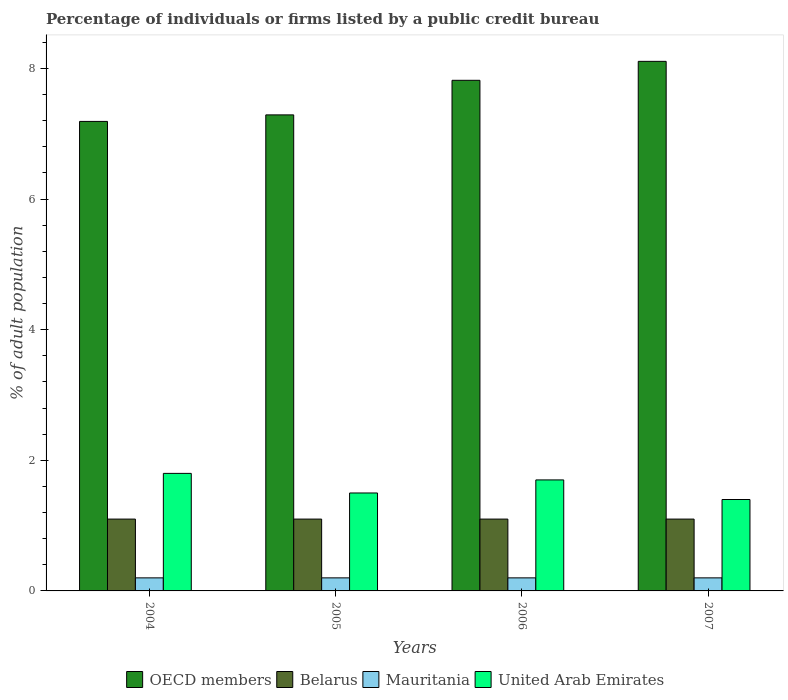How many groups of bars are there?
Keep it short and to the point. 4. Are the number of bars per tick equal to the number of legend labels?
Offer a terse response. Yes. Are the number of bars on each tick of the X-axis equal?
Give a very brief answer. Yes. How many bars are there on the 4th tick from the left?
Ensure brevity in your answer.  4. How many bars are there on the 1st tick from the right?
Provide a short and direct response. 4. Across all years, what is the maximum percentage of population listed by a public credit bureau in Belarus?
Your response must be concise. 1.1. In which year was the percentage of population listed by a public credit bureau in Belarus minimum?
Provide a succinct answer. 2004. What is the total percentage of population listed by a public credit bureau in Mauritania in the graph?
Give a very brief answer. 0.8. What is the difference between the percentage of population listed by a public credit bureau in OECD members in 2007 and the percentage of population listed by a public credit bureau in Mauritania in 2004?
Provide a short and direct response. 7.91. In the year 2006, what is the difference between the percentage of population listed by a public credit bureau in United Arab Emirates and percentage of population listed by a public credit bureau in Belarus?
Give a very brief answer. 0.6. What is the ratio of the percentage of population listed by a public credit bureau in OECD members in 2005 to that in 2006?
Make the answer very short. 0.93. Is the percentage of population listed by a public credit bureau in Mauritania in 2004 less than that in 2007?
Your response must be concise. No. What is the difference between the highest and the second highest percentage of population listed by a public credit bureau in United Arab Emirates?
Your response must be concise. 0.1. Is the sum of the percentage of population listed by a public credit bureau in Mauritania in 2006 and 2007 greater than the maximum percentage of population listed by a public credit bureau in Belarus across all years?
Offer a very short reply. No. Is it the case that in every year, the sum of the percentage of population listed by a public credit bureau in United Arab Emirates and percentage of population listed by a public credit bureau in OECD members is greater than the sum of percentage of population listed by a public credit bureau in Belarus and percentage of population listed by a public credit bureau in Mauritania?
Offer a very short reply. Yes. What does the 1st bar from the left in 2005 represents?
Give a very brief answer. OECD members. What does the 3rd bar from the right in 2007 represents?
Your answer should be compact. Belarus. Are all the bars in the graph horizontal?
Provide a short and direct response. No. How many years are there in the graph?
Give a very brief answer. 4. Where does the legend appear in the graph?
Your answer should be very brief. Bottom center. How are the legend labels stacked?
Your answer should be very brief. Horizontal. What is the title of the graph?
Provide a short and direct response. Percentage of individuals or firms listed by a public credit bureau. What is the label or title of the X-axis?
Ensure brevity in your answer.  Years. What is the label or title of the Y-axis?
Ensure brevity in your answer.  % of adult population. What is the % of adult population of OECD members in 2004?
Provide a succinct answer. 7.19. What is the % of adult population of United Arab Emirates in 2004?
Offer a very short reply. 1.8. What is the % of adult population in OECD members in 2005?
Offer a terse response. 7.29. What is the % of adult population in United Arab Emirates in 2005?
Make the answer very short. 1.5. What is the % of adult population of OECD members in 2006?
Provide a short and direct response. 7.82. What is the % of adult population in United Arab Emirates in 2006?
Ensure brevity in your answer.  1.7. What is the % of adult population in OECD members in 2007?
Make the answer very short. 8.11. What is the % of adult population of Belarus in 2007?
Provide a short and direct response. 1.1. Across all years, what is the maximum % of adult population in OECD members?
Your answer should be very brief. 8.11. Across all years, what is the maximum % of adult population in Mauritania?
Your response must be concise. 0.2. Across all years, what is the maximum % of adult population in United Arab Emirates?
Your answer should be very brief. 1.8. Across all years, what is the minimum % of adult population in OECD members?
Your response must be concise. 7.19. Across all years, what is the minimum % of adult population of Belarus?
Keep it short and to the point. 1.1. Across all years, what is the minimum % of adult population in Mauritania?
Keep it short and to the point. 0.2. Across all years, what is the minimum % of adult population of United Arab Emirates?
Ensure brevity in your answer.  1.4. What is the total % of adult population of OECD members in the graph?
Provide a short and direct response. 30.41. What is the total % of adult population of Belarus in the graph?
Offer a terse response. 4.4. What is the total % of adult population in Mauritania in the graph?
Your answer should be very brief. 0.8. What is the difference between the % of adult population of United Arab Emirates in 2004 and that in 2005?
Provide a succinct answer. 0.3. What is the difference between the % of adult population of OECD members in 2004 and that in 2006?
Keep it short and to the point. -0.63. What is the difference between the % of adult population of United Arab Emirates in 2004 and that in 2006?
Give a very brief answer. 0.1. What is the difference between the % of adult population of OECD members in 2004 and that in 2007?
Offer a terse response. -0.92. What is the difference between the % of adult population in Mauritania in 2004 and that in 2007?
Provide a short and direct response. 0. What is the difference between the % of adult population of United Arab Emirates in 2004 and that in 2007?
Make the answer very short. 0.4. What is the difference between the % of adult population in OECD members in 2005 and that in 2006?
Offer a very short reply. -0.53. What is the difference between the % of adult population of United Arab Emirates in 2005 and that in 2006?
Give a very brief answer. -0.2. What is the difference between the % of adult population in OECD members in 2005 and that in 2007?
Your answer should be compact. -0.82. What is the difference between the % of adult population of Belarus in 2005 and that in 2007?
Offer a very short reply. 0. What is the difference between the % of adult population in Mauritania in 2005 and that in 2007?
Provide a short and direct response. 0. What is the difference between the % of adult population in OECD members in 2006 and that in 2007?
Give a very brief answer. -0.29. What is the difference between the % of adult population of Mauritania in 2006 and that in 2007?
Keep it short and to the point. 0. What is the difference between the % of adult population in OECD members in 2004 and the % of adult population in Belarus in 2005?
Your response must be concise. 6.09. What is the difference between the % of adult population in OECD members in 2004 and the % of adult population in Mauritania in 2005?
Your answer should be very brief. 6.99. What is the difference between the % of adult population of OECD members in 2004 and the % of adult population of United Arab Emirates in 2005?
Make the answer very short. 5.69. What is the difference between the % of adult population of Belarus in 2004 and the % of adult population of Mauritania in 2005?
Provide a succinct answer. 0.9. What is the difference between the % of adult population in Belarus in 2004 and the % of adult population in United Arab Emirates in 2005?
Offer a very short reply. -0.4. What is the difference between the % of adult population in Mauritania in 2004 and the % of adult population in United Arab Emirates in 2005?
Offer a very short reply. -1.3. What is the difference between the % of adult population of OECD members in 2004 and the % of adult population of Belarus in 2006?
Provide a short and direct response. 6.09. What is the difference between the % of adult population in OECD members in 2004 and the % of adult population in Mauritania in 2006?
Your answer should be compact. 6.99. What is the difference between the % of adult population of OECD members in 2004 and the % of adult population of United Arab Emirates in 2006?
Provide a succinct answer. 5.49. What is the difference between the % of adult population of Belarus in 2004 and the % of adult population of United Arab Emirates in 2006?
Your answer should be compact. -0.6. What is the difference between the % of adult population of OECD members in 2004 and the % of adult population of Belarus in 2007?
Provide a short and direct response. 6.09. What is the difference between the % of adult population of OECD members in 2004 and the % of adult population of Mauritania in 2007?
Provide a short and direct response. 6.99. What is the difference between the % of adult population of OECD members in 2004 and the % of adult population of United Arab Emirates in 2007?
Provide a short and direct response. 5.79. What is the difference between the % of adult population of OECD members in 2005 and the % of adult population of Belarus in 2006?
Your answer should be compact. 6.19. What is the difference between the % of adult population of OECD members in 2005 and the % of adult population of Mauritania in 2006?
Provide a succinct answer. 7.09. What is the difference between the % of adult population of OECD members in 2005 and the % of adult population of United Arab Emirates in 2006?
Give a very brief answer. 5.59. What is the difference between the % of adult population in Belarus in 2005 and the % of adult population in Mauritania in 2006?
Provide a succinct answer. 0.9. What is the difference between the % of adult population of Belarus in 2005 and the % of adult population of United Arab Emirates in 2006?
Provide a succinct answer. -0.6. What is the difference between the % of adult population in Mauritania in 2005 and the % of adult population in United Arab Emirates in 2006?
Give a very brief answer. -1.5. What is the difference between the % of adult population in OECD members in 2005 and the % of adult population in Belarus in 2007?
Offer a very short reply. 6.19. What is the difference between the % of adult population in OECD members in 2005 and the % of adult population in Mauritania in 2007?
Make the answer very short. 7.09. What is the difference between the % of adult population in OECD members in 2005 and the % of adult population in United Arab Emirates in 2007?
Your answer should be compact. 5.89. What is the difference between the % of adult population of Belarus in 2005 and the % of adult population of Mauritania in 2007?
Your answer should be very brief. 0.9. What is the difference between the % of adult population in OECD members in 2006 and the % of adult population in Belarus in 2007?
Give a very brief answer. 6.72. What is the difference between the % of adult population of OECD members in 2006 and the % of adult population of Mauritania in 2007?
Ensure brevity in your answer.  7.62. What is the difference between the % of adult population of OECD members in 2006 and the % of adult population of United Arab Emirates in 2007?
Make the answer very short. 6.42. What is the average % of adult population in OECD members per year?
Make the answer very short. 7.6. What is the average % of adult population of Mauritania per year?
Give a very brief answer. 0.2. In the year 2004, what is the difference between the % of adult population in OECD members and % of adult population in Belarus?
Keep it short and to the point. 6.09. In the year 2004, what is the difference between the % of adult population in OECD members and % of adult population in Mauritania?
Offer a terse response. 6.99. In the year 2004, what is the difference between the % of adult population in OECD members and % of adult population in United Arab Emirates?
Your response must be concise. 5.39. In the year 2005, what is the difference between the % of adult population in OECD members and % of adult population in Belarus?
Your response must be concise. 6.19. In the year 2005, what is the difference between the % of adult population of OECD members and % of adult population of Mauritania?
Your answer should be very brief. 7.09. In the year 2005, what is the difference between the % of adult population of OECD members and % of adult population of United Arab Emirates?
Provide a succinct answer. 5.79. In the year 2006, what is the difference between the % of adult population of OECD members and % of adult population of Belarus?
Provide a short and direct response. 6.72. In the year 2006, what is the difference between the % of adult population in OECD members and % of adult population in Mauritania?
Keep it short and to the point. 7.62. In the year 2006, what is the difference between the % of adult population in OECD members and % of adult population in United Arab Emirates?
Your answer should be compact. 6.12. In the year 2006, what is the difference between the % of adult population of Belarus and % of adult population of Mauritania?
Provide a succinct answer. 0.9. In the year 2006, what is the difference between the % of adult population in Belarus and % of adult population in United Arab Emirates?
Provide a short and direct response. -0.6. In the year 2006, what is the difference between the % of adult population in Mauritania and % of adult population in United Arab Emirates?
Offer a very short reply. -1.5. In the year 2007, what is the difference between the % of adult population of OECD members and % of adult population of Belarus?
Ensure brevity in your answer.  7.01. In the year 2007, what is the difference between the % of adult population in OECD members and % of adult population in Mauritania?
Offer a very short reply. 7.91. In the year 2007, what is the difference between the % of adult population in OECD members and % of adult population in United Arab Emirates?
Offer a terse response. 6.71. What is the ratio of the % of adult population in OECD members in 2004 to that in 2005?
Make the answer very short. 0.99. What is the ratio of the % of adult population of United Arab Emirates in 2004 to that in 2005?
Provide a short and direct response. 1.2. What is the ratio of the % of adult population in OECD members in 2004 to that in 2006?
Give a very brief answer. 0.92. What is the ratio of the % of adult population in Belarus in 2004 to that in 2006?
Ensure brevity in your answer.  1. What is the ratio of the % of adult population of United Arab Emirates in 2004 to that in 2006?
Provide a short and direct response. 1.06. What is the ratio of the % of adult population in OECD members in 2004 to that in 2007?
Keep it short and to the point. 0.89. What is the ratio of the % of adult population of Belarus in 2004 to that in 2007?
Your response must be concise. 1. What is the ratio of the % of adult population of OECD members in 2005 to that in 2006?
Provide a short and direct response. 0.93. What is the ratio of the % of adult population of Belarus in 2005 to that in 2006?
Give a very brief answer. 1. What is the ratio of the % of adult population of United Arab Emirates in 2005 to that in 2006?
Your response must be concise. 0.88. What is the ratio of the % of adult population in OECD members in 2005 to that in 2007?
Offer a very short reply. 0.9. What is the ratio of the % of adult population of Belarus in 2005 to that in 2007?
Your answer should be very brief. 1. What is the ratio of the % of adult population of Mauritania in 2005 to that in 2007?
Your answer should be compact. 1. What is the ratio of the % of adult population in United Arab Emirates in 2005 to that in 2007?
Make the answer very short. 1.07. What is the ratio of the % of adult population of OECD members in 2006 to that in 2007?
Provide a short and direct response. 0.96. What is the ratio of the % of adult population of Belarus in 2006 to that in 2007?
Provide a short and direct response. 1. What is the ratio of the % of adult population of Mauritania in 2006 to that in 2007?
Your answer should be compact. 1. What is the ratio of the % of adult population in United Arab Emirates in 2006 to that in 2007?
Offer a terse response. 1.21. What is the difference between the highest and the second highest % of adult population in OECD members?
Your answer should be compact. 0.29. What is the difference between the highest and the second highest % of adult population in Belarus?
Your response must be concise. 0. What is the difference between the highest and the second highest % of adult population in United Arab Emirates?
Your answer should be compact. 0.1. What is the difference between the highest and the lowest % of adult population in OECD members?
Ensure brevity in your answer.  0.92. 